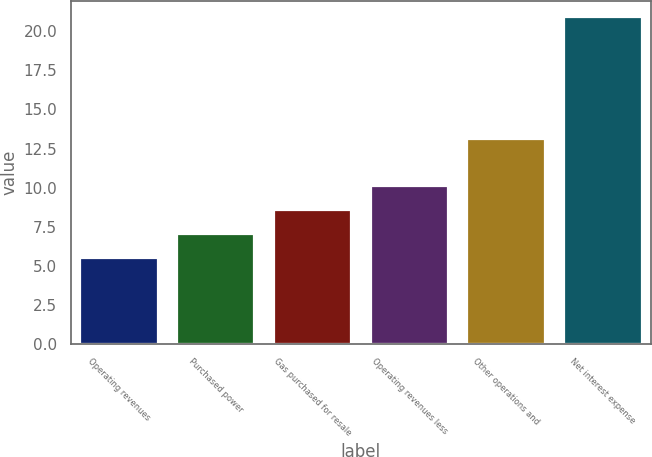Convert chart. <chart><loc_0><loc_0><loc_500><loc_500><bar_chart><fcel>Operating revenues<fcel>Purchased power<fcel>Gas purchased for resale<fcel>Operating revenues less<fcel>Other operations and<fcel>Net interest expense<nl><fcel>5.5<fcel>7.04<fcel>8.58<fcel>10.12<fcel>13.1<fcel>20.9<nl></chart> 